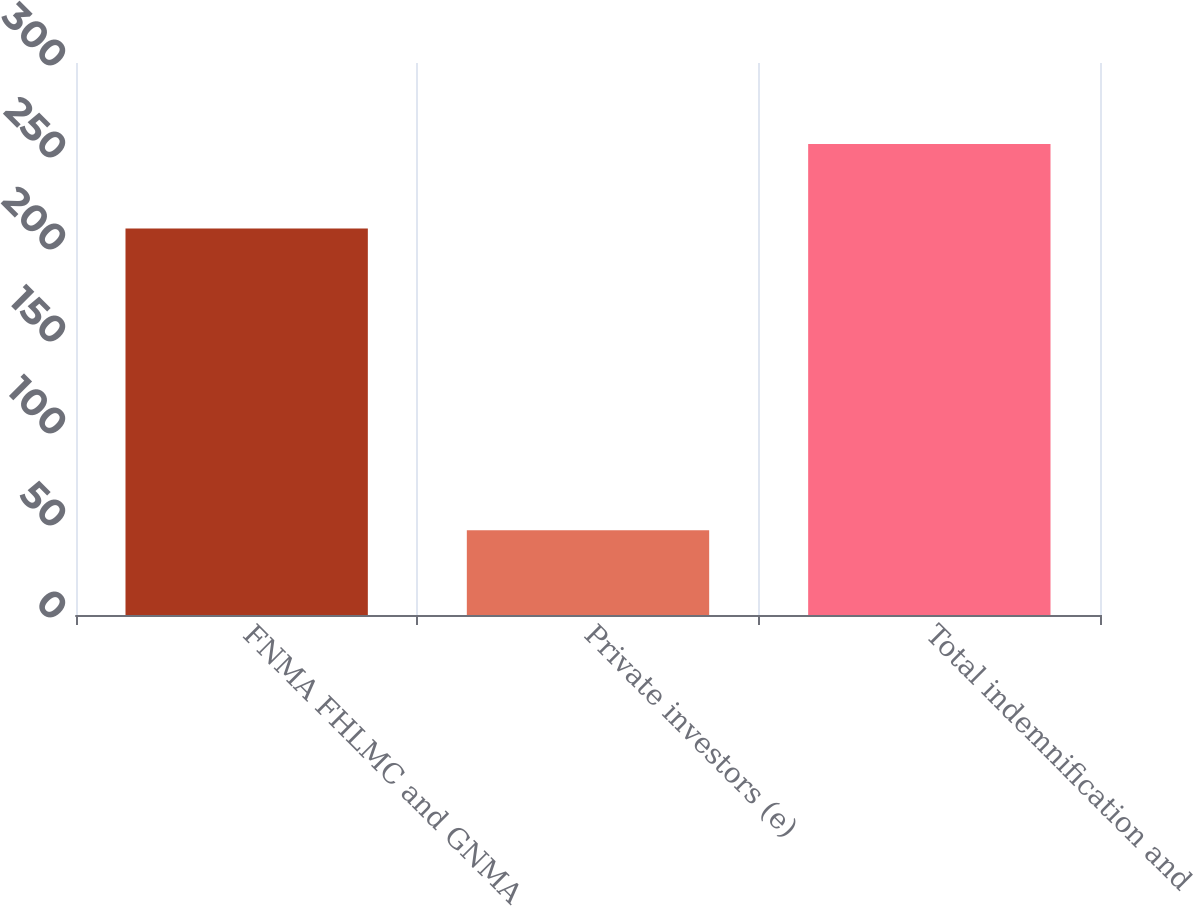<chart> <loc_0><loc_0><loc_500><loc_500><bar_chart><fcel>FNMA FHLMC and GNMA<fcel>Private investors (e)<fcel>Total indemnification and<nl><fcel>210<fcel>46<fcel>256<nl></chart> 